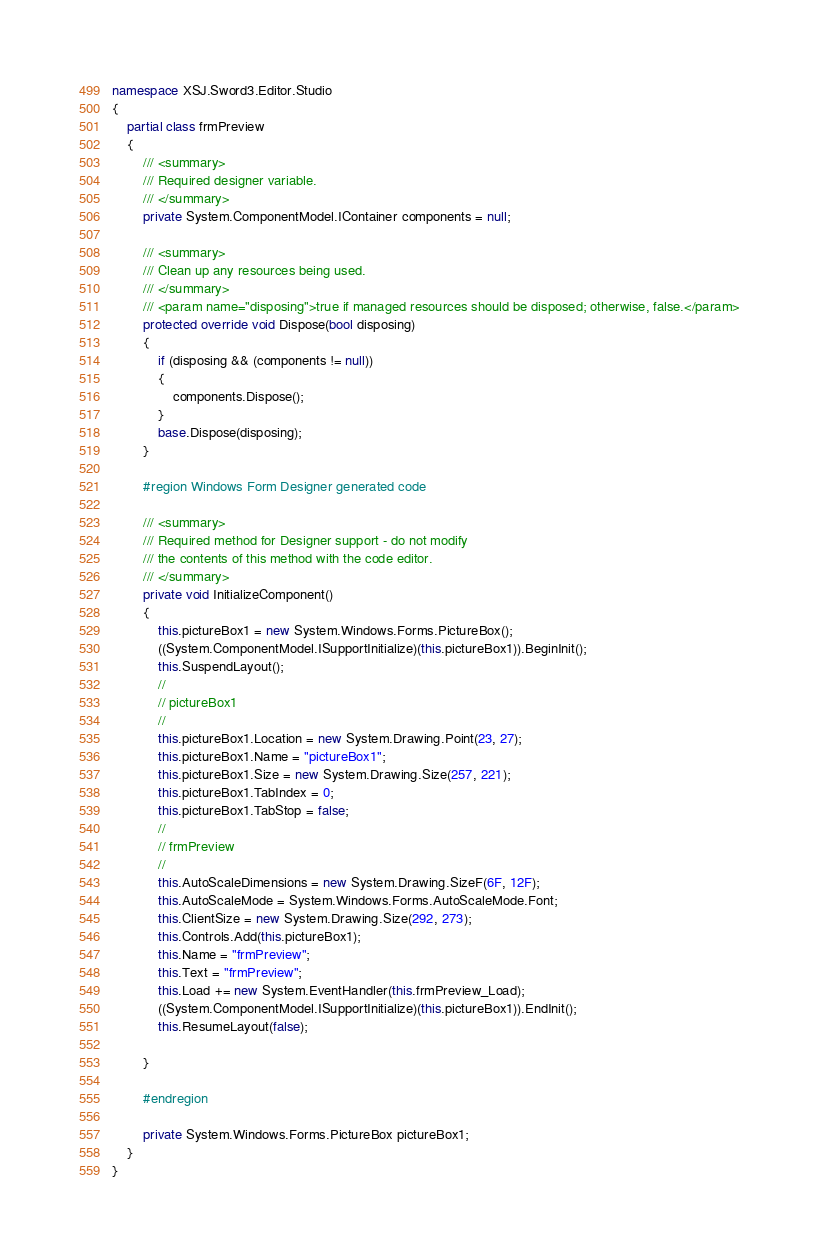Convert code to text. <code><loc_0><loc_0><loc_500><loc_500><_C#_>namespace XSJ.Sword3.Editor.Studio
{
    partial class frmPreview
    {
        /// <summary>
        /// Required designer variable.
        /// </summary>
        private System.ComponentModel.IContainer components = null;

        /// <summary>
        /// Clean up any resources being used.
        /// </summary>
        /// <param name="disposing">true if managed resources should be disposed; otherwise, false.</param>
        protected override void Dispose(bool disposing)
        {
            if (disposing && (components != null))
            {
                components.Dispose();
            }
            base.Dispose(disposing);
        }

        #region Windows Form Designer generated code

        /// <summary>
        /// Required method for Designer support - do not modify
        /// the contents of this method with the code editor.
        /// </summary>
        private void InitializeComponent()
        {
            this.pictureBox1 = new System.Windows.Forms.PictureBox();
            ((System.ComponentModel.ISupportInitialize)(this.pictureBox1)).BeginInit();
            this.SuspendLayout();
            // 
            // pictureBox1
            // 
            this.pictureBox1.Location = new System.Drawing.Point(23, 27);
            this.pictureBox1.Name = "pictureBox1";
            this.pictureBox1.Size = new System.Drawing.Size(257, 221);
            this.pictureBox1.TabIndex = 0;
            this.pictureBox1.TabStop = false;
            // 
            // frmPreview
            // 
            this.AutoScaleDimensions = new System.Drawing.SizeF(6F, 12F);
            this.AutoScaleMode = System.Windows.Forms.AutoScaleMode.Font;
            this.ClientSize = new System.Drawing.Size(292, 273);
            this.Controls.Add(this.pictureBox1);
            this.Name = "frmPreview";
            this.Text = "frmPreview";
            this.Load += new System.EventHandler(this.frmPreview_Load);
            ((System.ComponentModel.ISupportInitialize)(this.pictureBox1)).EndInit();
            this.ResumeLayout(false);

        }

        #endregion

        private System.Windows.Forms.PictureBox pictureBox1;
    }
}</code> 